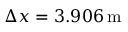<formula> <loc_0><loc_0><loc_500><loc_500>\Delta x = 3 . 9 0 6 \, m</formula> 